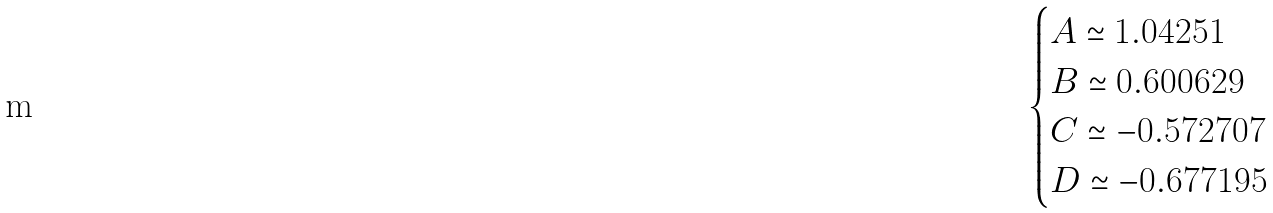Convert formula to latex. <formula><loc_0><loc_0><loc_500><loc_500>\begin{cases} A \simeq 1 . 0 4 2 5 1 \\ B \simeq 0 . 6 0 0 6 2 9 \\ C \simeq - 0 . 5 7 2 7 0 7 \\ D \simeq - 0 . 6 7 7 1 9 5 \end{cases}</formula> 